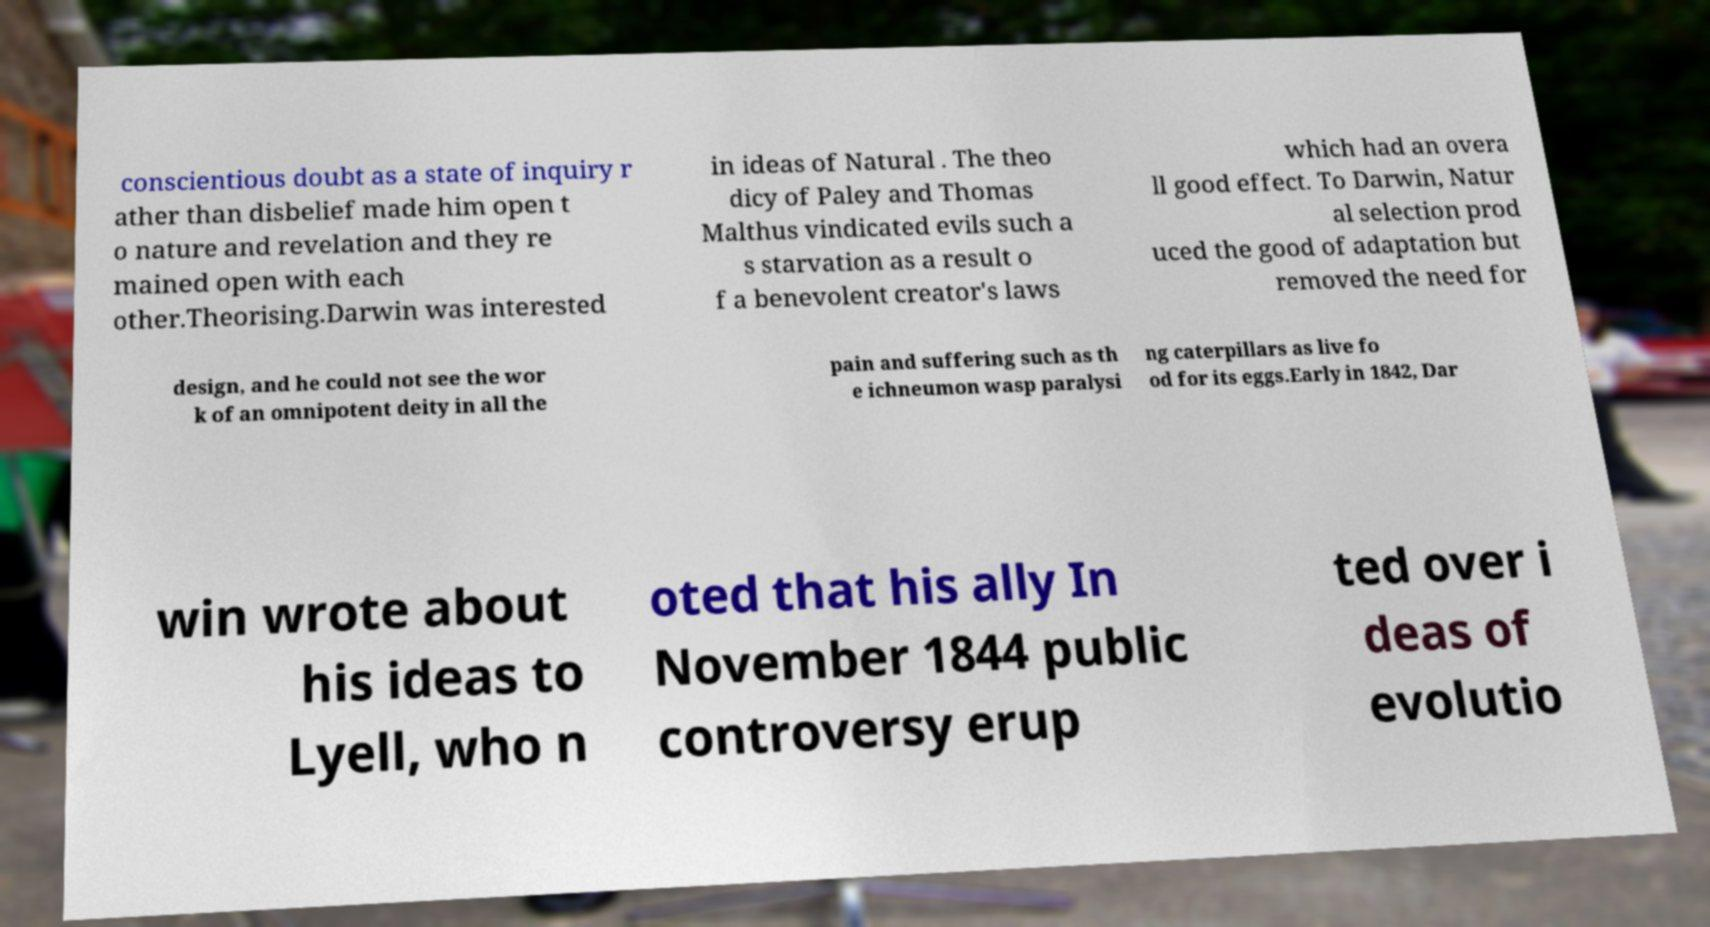There's text embedded in this image that I need extracted. Can you transcribe it verbatim? conscientious doubt as a state of inquiry r ather than disbelief made him open t o nature and revelation and they re mained open with each other.Theorising.Darwin was interested in ideas of Natural . The theo dicy of Paley and Thomas Malthus vindicated evils such a s starvation as a result o f a benevolent creator's laws which had an overa ll good effect. To Darwin, Natur al selection prod uced the good of adaptation but removed the need for design, and he could not see the wor k of an omnipotent deity in all the pain and suffering such as th e ichneumon wasp paralysi ng caterpillars as live fo od for its eggs.Early in 1842, Dar win wrote about his ideas to Lyell, who n oted that his ally In November 1844 public controversy erup ted over i deas of evolutio 